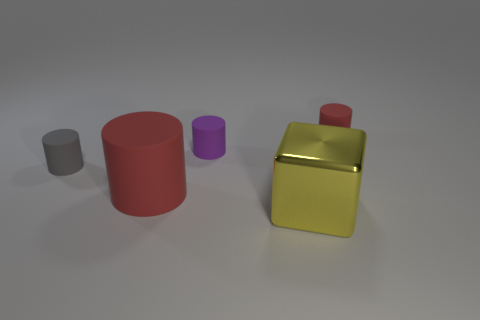What shape is the object that is right of the purple object and behind the yellow cube?
Keep it short and to the point. Cylinder. Are there fewer small red cylinders than tiny rubber objects?
Offer a very short reply. Yes. Are any small cyan rubber objects visible?
Provide a short and direct response. No. What number of other things are there of the same size as the gray object?
Provide a short and direct response. 2. Are the gray cylinder and the red cylinder on the left side of the big yellow block made of the same material?
Provide a short and direct response. Yes. Are there the same number of purple objects behind the big red matte object and big red cylinders to the right of the tiny purple cylinder?
Make the answer very short. No. What material is the gray cylinder?
Give a very brief answer. Rubber. There is a thing that is the same size as the metal cube; what color is it?
Provide a succinct answer. Red. There is a red rubber cylinder that is in front of the small gray matte thing; are there any shiny blocks in front of it?
Your response must be concise. Yes. What number of spheres are either red things or tiny purple things?
Provide a succinct answer. 0. 